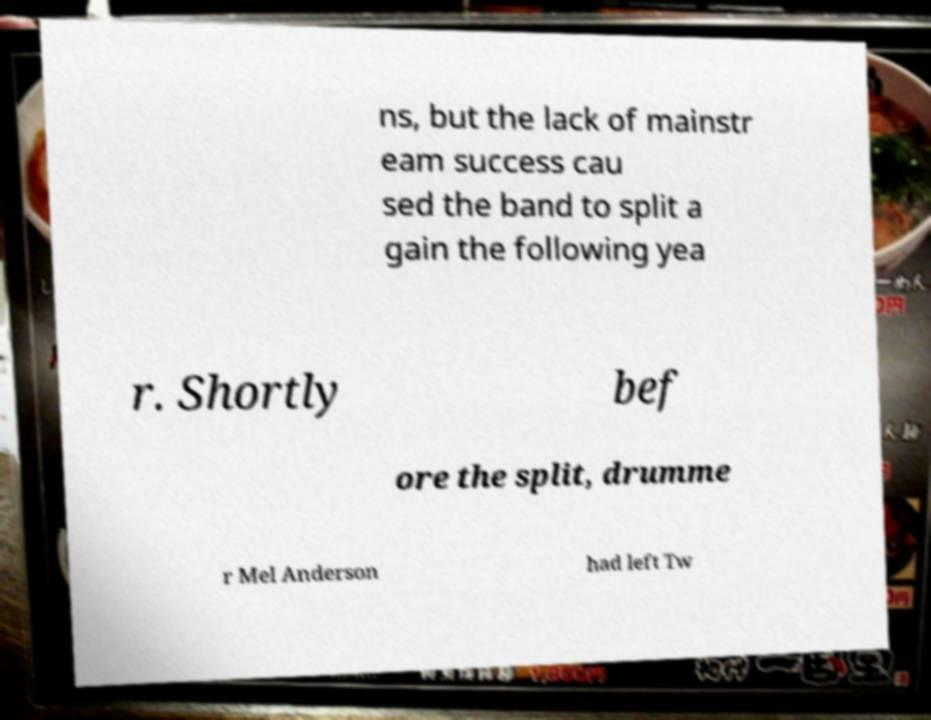Can you accurately transcribe the text from the provided image for me? ns, but the lack of mainstr eam success cau sed the band to split a gain the following yea r. Shortly bef ore the split, drumme r Mel Anderson had left Tw 